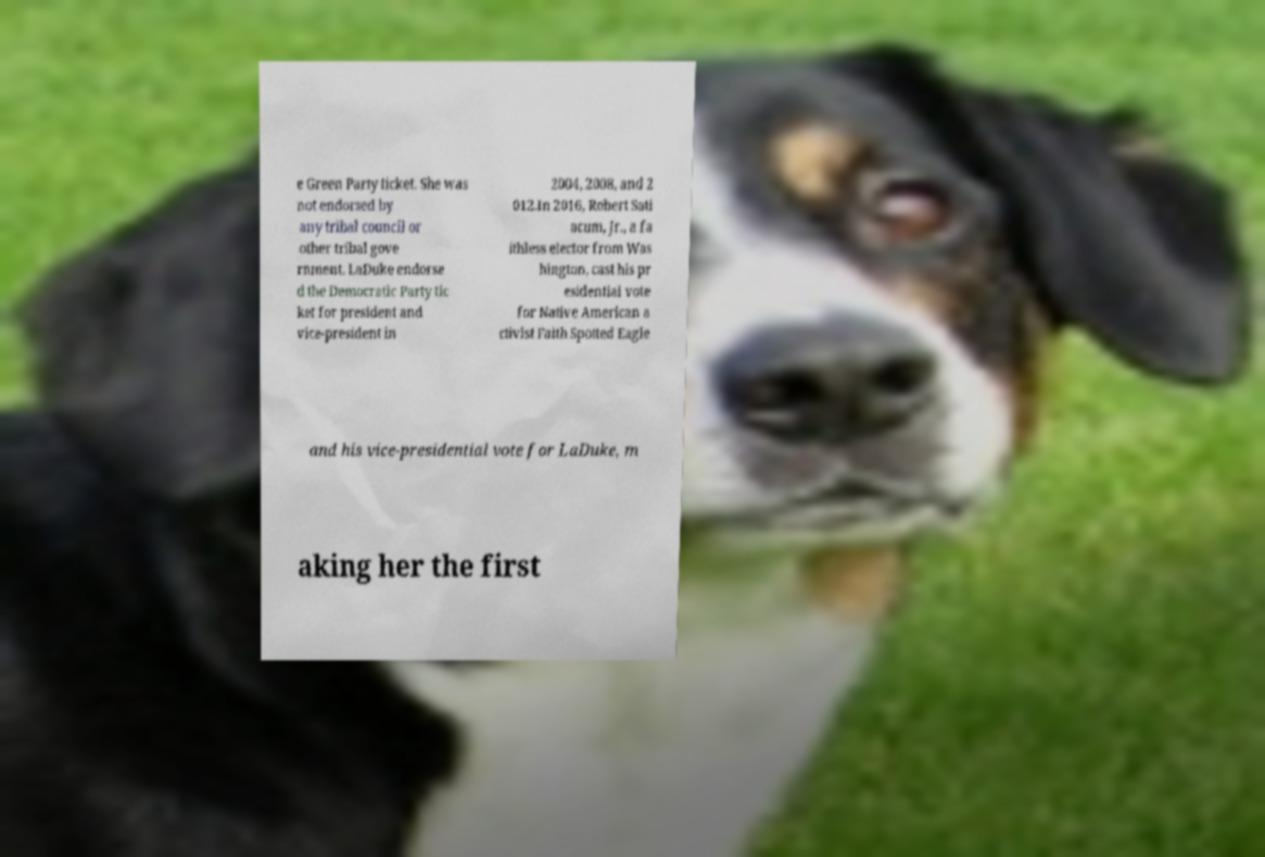Can you accurately transcribe the text from the provided image for me? e Green Party ticket. She was not endorsed by any tribal council or other tribal gove rnment. LaDuke endorse d the Democratic Party tic ket for president and vice-president in 2004, 2008, and 2 012.In 2016, Robert Sati acum, Jr., a fa ithless elector from Was hington, cast his pr esidential vote for Native American a ctivist Faith Spotted Eagle and his vice-presidential vote for LaDuke, m aking her the first 